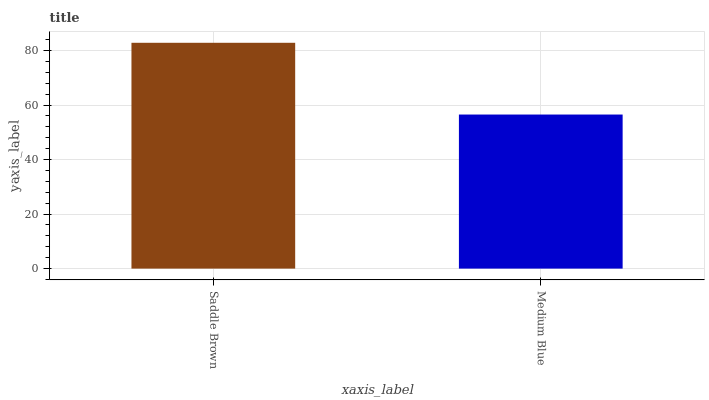Is Medium Blue the maximum?
Answer yes or no. No. Is Saddle Brown greater than Medium Blue?
Answer yes or no. Yes. Is Medium Blue less than Saddle Brown?
Answer yes or no. Yes. Is Medium Blue greater than Saddle Brown?
Answer yes or no. No. Is Saddle Brown less than Medium Blue?
Answer yes or no. No. Is Saddle Brown the high median?
Answer yes or no. Yes. Is Medium Blue the low median?
Answer yes or no. Yes. Is Medium Blue the high median?
Answer yes or no. No. Is Saddle Brown the low median?
Answer yes or no. No. 